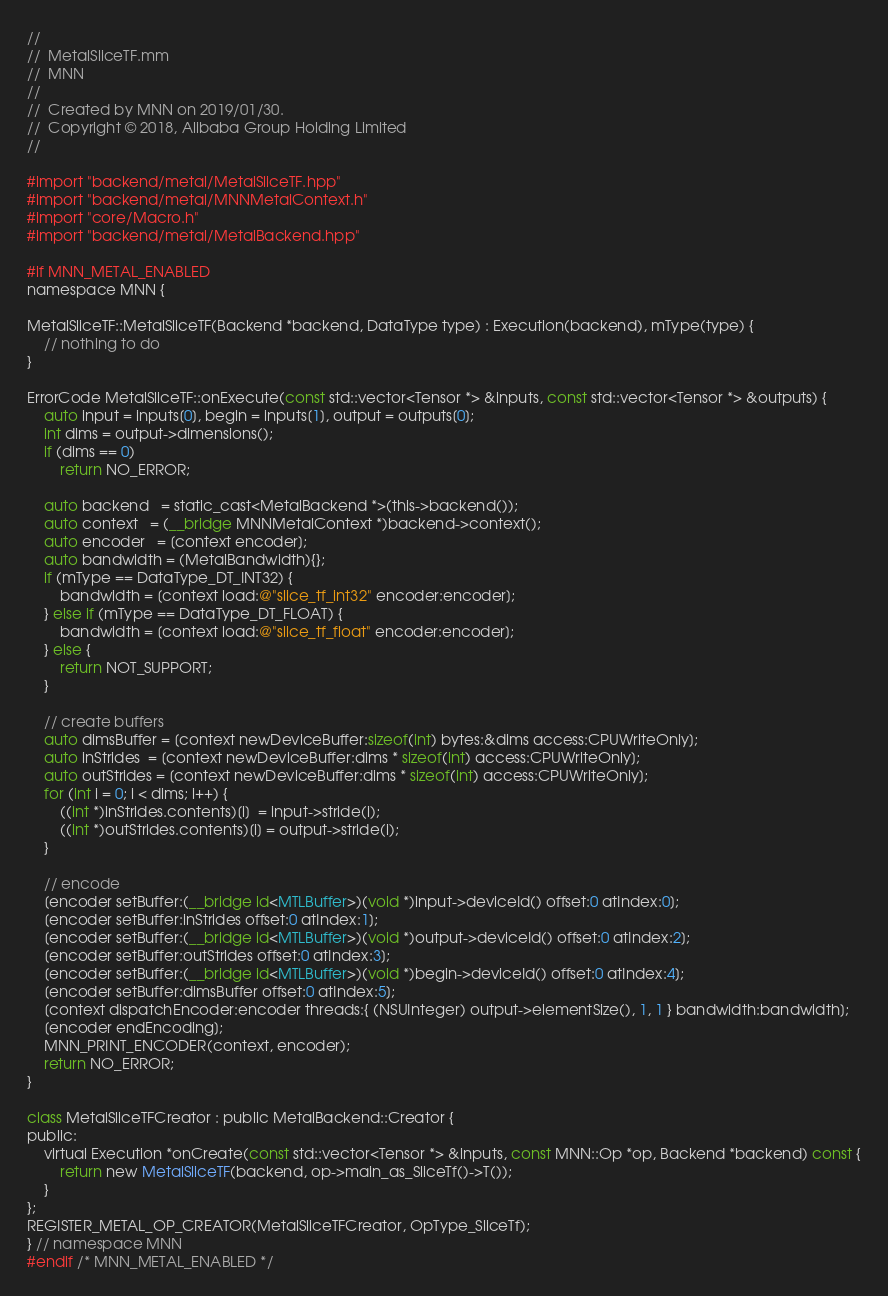<code> <loc_0><loc_0><loc_500><loc_500><_ObjectiveC_>//
//  MetalSliceTF.mm
//  MNN
//
//  Created by MNN on 2019/01/30.
//  Copyright © 2018, Alibaba Group Holding Limited
//

#import "backend/metal/MetalSliceTF.hpp"
#import "backend/metal/MNNMetalContext.h"
#import "core/Macro.h"
#import "backend/metal/MetalBackend.hpp"

#if MNN_METAL_ENABLED
namespace MNN {

MetalSliceTF::MetalSliceTF(Backend *backend, DataType type) : Execution(backend), mType(type) {
    // nothing to do
}

ErrorCode MetalSliceTF::onExecute(const std::vector<Tensor *> &inputs, const std::vector<Tensor *> &outputs) {
    auto input = inputs[0], begin = inputs[1], output = outputs[0];
    int dims = output->dimensions();
    if (dims == 0)
        return NO_ERROR;

    auto backend   = static_cast<MetalBackend *>(this->backend());
    auto context   = (__bridge MNNMetalContext *)backend->context();
    auto encoder   = [context encoder];
    auto bandwidth = (MetalBandwidth){};
    if (mType == DataType_DT_INT32) {
        bandwidth = [context load:@"slice_tf_int32" encoder:encoder];
    } else if (mType == DataType_DT_FLOAT) {
        bandwidth = [context load:@"slice_tf_float" encoder:encoder];
    } else {
        return NOT_SUPPORT;
    }

    // create buffers
    auto dimsBuffer = [context newDeviceBuffer:sizeof(int) bytes:&dims access:CPUWriteOnly];
    auto inStrides  = [context newDeviceBuffer:dims * sizeof(int) access:CPUWriteOnly];
    auto outStrides = [context newDeviceBuffer:dims * sizeof(int) access:CPUWriteOnly];
    for (int i = 0; i < dims; i++) {
        ((int *)inStrides.contents)[i]  = input->stride(i);
        ((int *)outStrides.contents)[i] = output->stride(i);
    }

    // encode
    [encoder setBuffer:(__bridge id<MTLBuffer>)(void *)input->deviceId() offset:0 atIndex:0];
    [encoder setBuffer:inStrides offset:0 atIndex:1];
    [encoder setBuffer:(__bridge id<MTLBuffer>)(void *)output->deviceId() offset:0 atIndex:2];
    [encoder setBuffer:outStrides offset:0 atIndex:3];
    [encoder setBuffer:(__bridge id<MTLBuffer>)(void *)begin->deviceId() offset:0 atIndex:4];
    [encoder setBuffer:dimsBuffer offset:0 atIndex:5];
    [context dispatchEncoder:encoder threads:{ (NSUInteger) output->elementSize(), 1, 1 } bandwidth:bandwidth];
    [encoder endEncoding];
    MNN_PRINT_ENCODER(context, encoder);
    return NO_ERROR;
}

class MetalSliceTFCreator : public MetalBackend::Creator {
public:
    virtual Execution *onCreate(const std::vector<Tensor *> &inputs, const MNN::Op *op, Backend *backend) const {
        return new MetalSliceTF(backend, op->main_as_SliceTf()->T());
    }
};
REGISTER_METAL_OP_CREATOR(MetalSliceTFCreator, OpType_SliceTf);
} // namespace MNN
#endif /* MNN_METAL_ENABLED */
</code> 